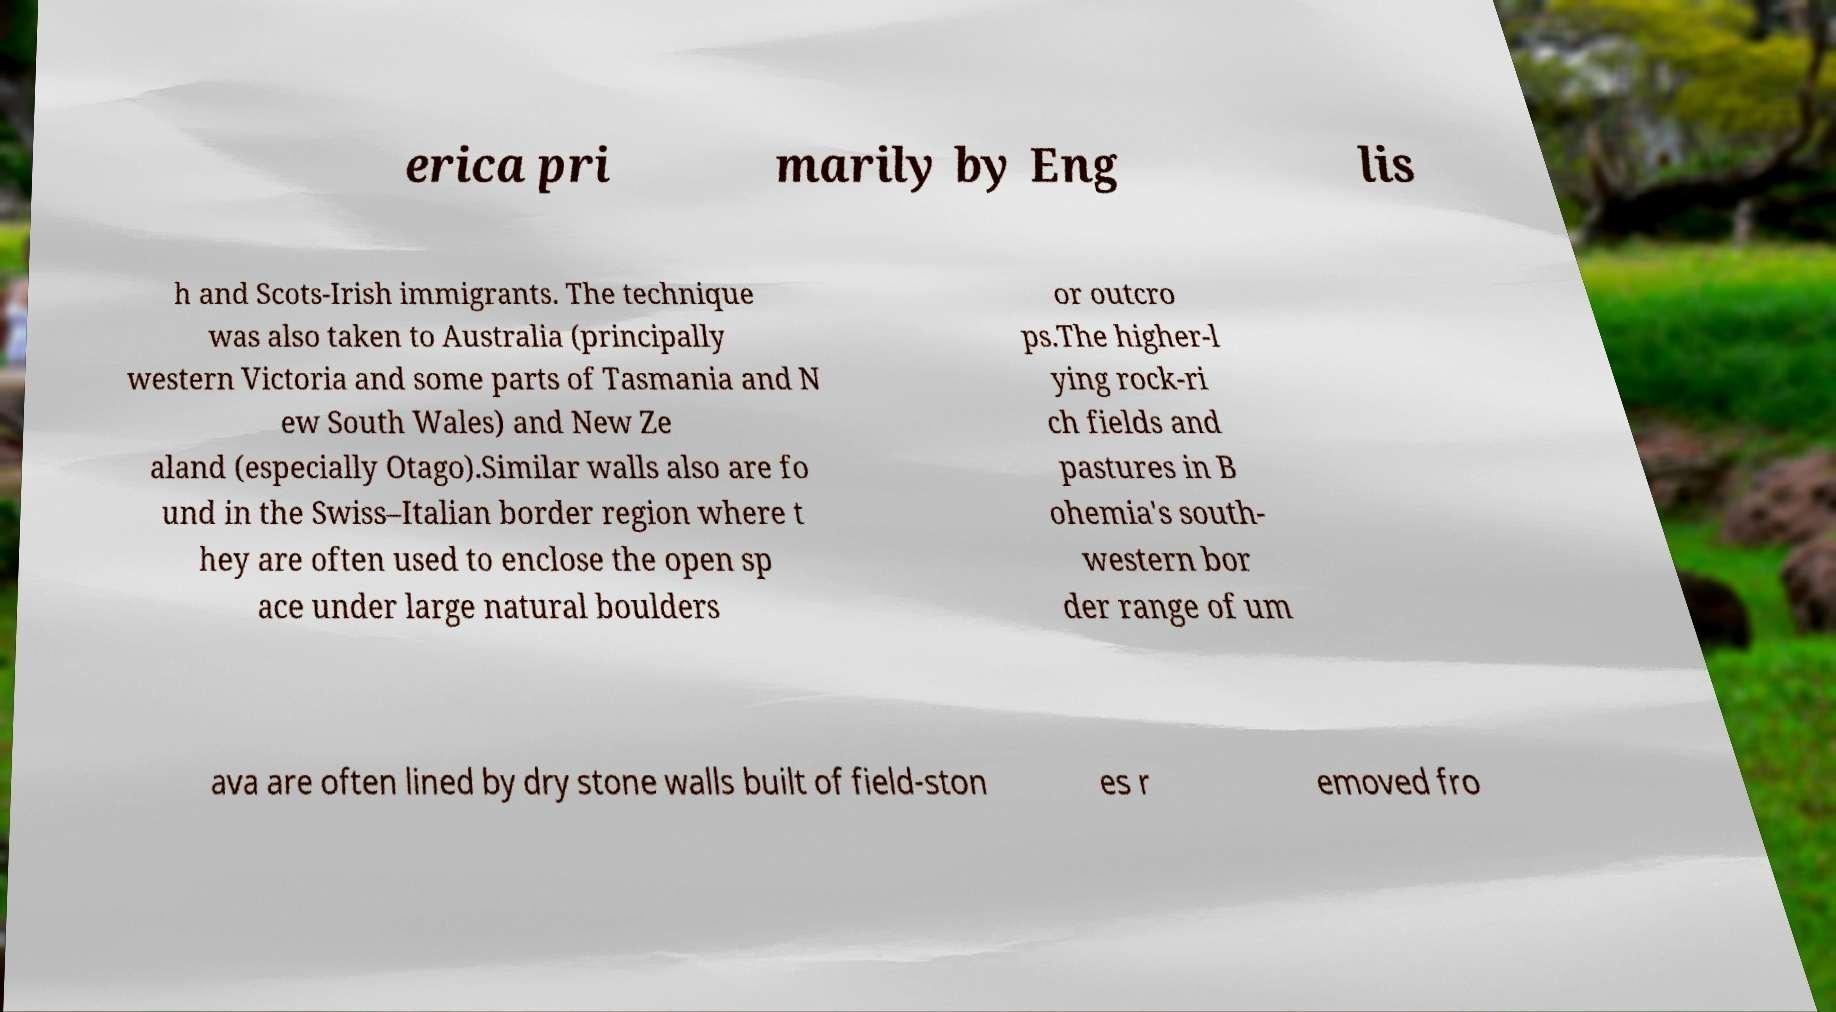Could you assist in decoding the text presented in this image and type it out clearly? erica pri marily by Eng lis h and Scots-Irish immigrants. The technique was also taken to Australia (principally western Victoria and some parts of Tasmania and N ew South Wales) and New Ze aland (especially Otago).Similar walls also are fo und in the Swiss–Italian border region where t hey are often used to enclose the open sp ace under large natural boulders or outcro ps.The higher-l ying rock-ri ch fields and pastures in B ohemia's south- western bor der range of um ava are often lined by dry stone walls built of field-ston es r emoved fro 